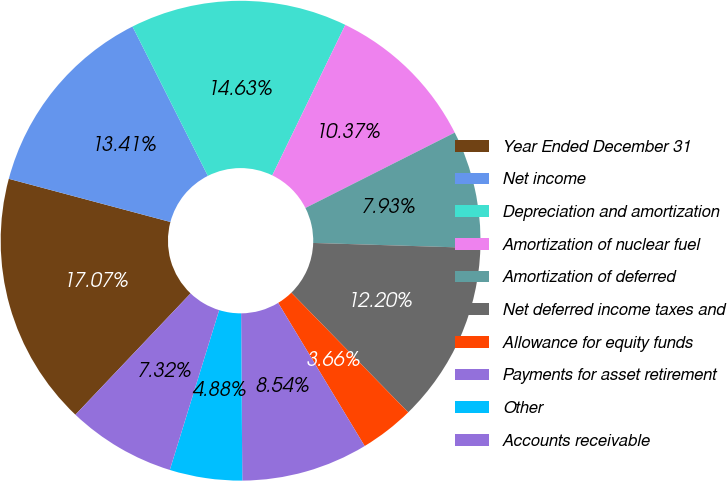<chart> <loc_0><loc_0><loc_500><loc_500><pie_chart><fcel>Year Ended December 31<fcel>Net income<fcel>Depreciation and amortization<fcel>Amortization of nuclear fuel<fcel>Amortization of deferred<fcel>Net deferred income taxes and<fcel>Allowance for equity funds<fcel>Payments for asset retirement<fcel>Other<fcel>Accounts receivable<nl><fcel>17.07%<fcel>13.41%<fcel>14.63%<fcel>10.37%<fcel>7.93%<fcel>12.2%<fcel>3.66%<fcel>8.54%<fcel>4.88%<fcel>7.32%<nl></chart> 